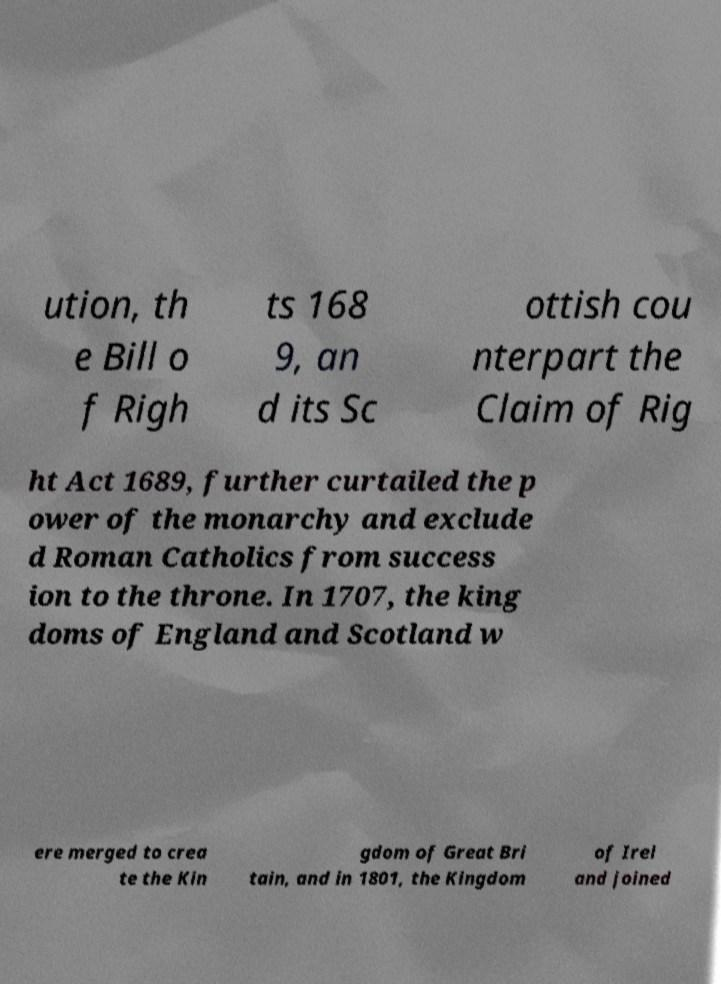I need the written content from this picture converted into text. Can you do that? ution, th e Bill o f Righ ts 168 9, an d its Sc ottish cou nterpart the Claim of Rig ht Act 1689, further curtailed the p ower of the monarchy and exclude d Roman Catholics from success ion to the throne. In 1707, the king doms of England and Scotland w ere merged to crea te the Kin gdom of Great Bri tain, and in 1801, the Kingdom of Irel and joined 